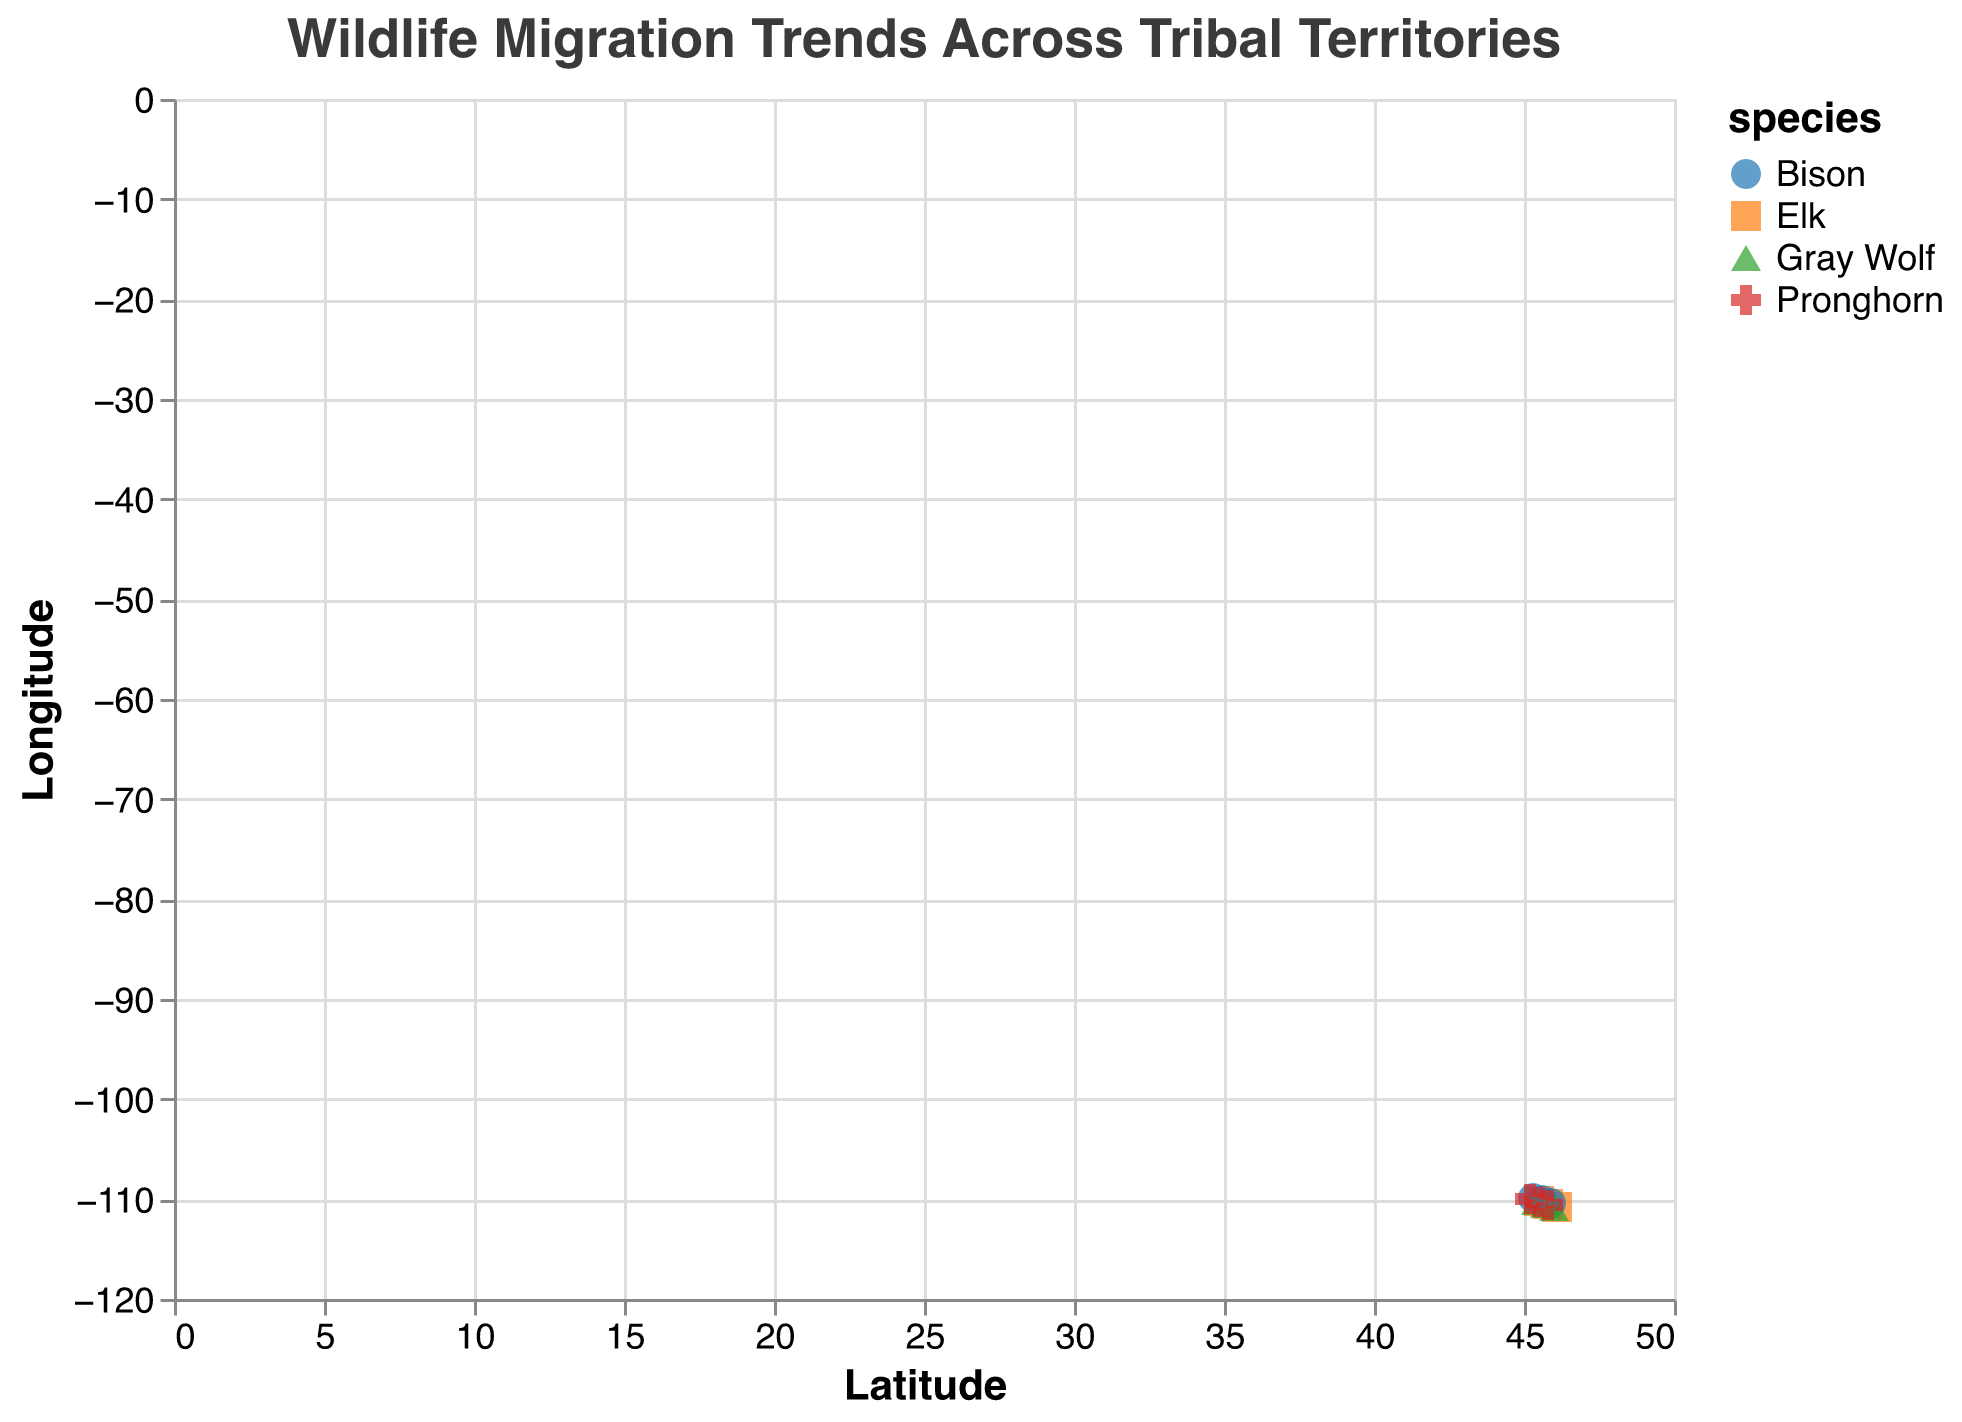How many different wildlife species are represented in the plot? By observing the legend, we can see that there are four distinct species, each represented by different colors and shapes.
Answer: Four What is the title of the figure? The title is displayed prominently at the top of the chart.
Answer: Wildlife Migration Trends Across Tribal Territories Which species shows a southern migration trend overall? By looking at the direction of the arrows, it is clear that the Gray Wolf mostly has arrows pointing downwards, indicating a southern migration.
Answer: Gray Wolf What is the migration direction of the Elk species at coordinates (45.5, -110.2)? The arrow at these coordinates for the Elk points slightly to the left and upwards. This indicates a northwest direction (-0.3 for x, 0.5 for y).
Answer: Northwest Which species has the longest arrow indicating the fastest migration? The length of the arrow is an indication of speed. By looking at the plot, the Bison at (45.9, -110.4) has the longest arrow.
Answer: Bison Compare the migration directions of the Bison and the Pronghorn at latitude 45.8. Bison at (45.9, -110.4) moves slightly to the east (0.5, -0.1), while Pronghorn at (45.8, -110.6) moves north-east (0.3, 0.4).
Answer: Bison moves east; Pronghorn moves north-east What is the average latitude of the data points for the Elk species? The data points for Elk are at latitudes 45.5, 45.8, and 46.1. The average is calculated by (45.5 + 45.8 + 46.1) / 3 = 45.8.
Answer: 45.8 Which species is found closest to the coordinate (46.0, -110.0)? By examining the coordinates, we see that the closest species is the Pronghorn at (45.8, -110.6), as it's the closest in terms of geographic proximity.
Answer: Pronghorn Determine the predominant migration direction for each species. By examining the directions of the arrows for each species:
- Elk mostly move north-west.
- Bison moves mostly east.
- Gray Wolf moves mostly south.
- Pronghorn moves mostly north-east.
Answer: Elk: NW, Bison: E, Gray Wolf: S, Pronghorn: NE 